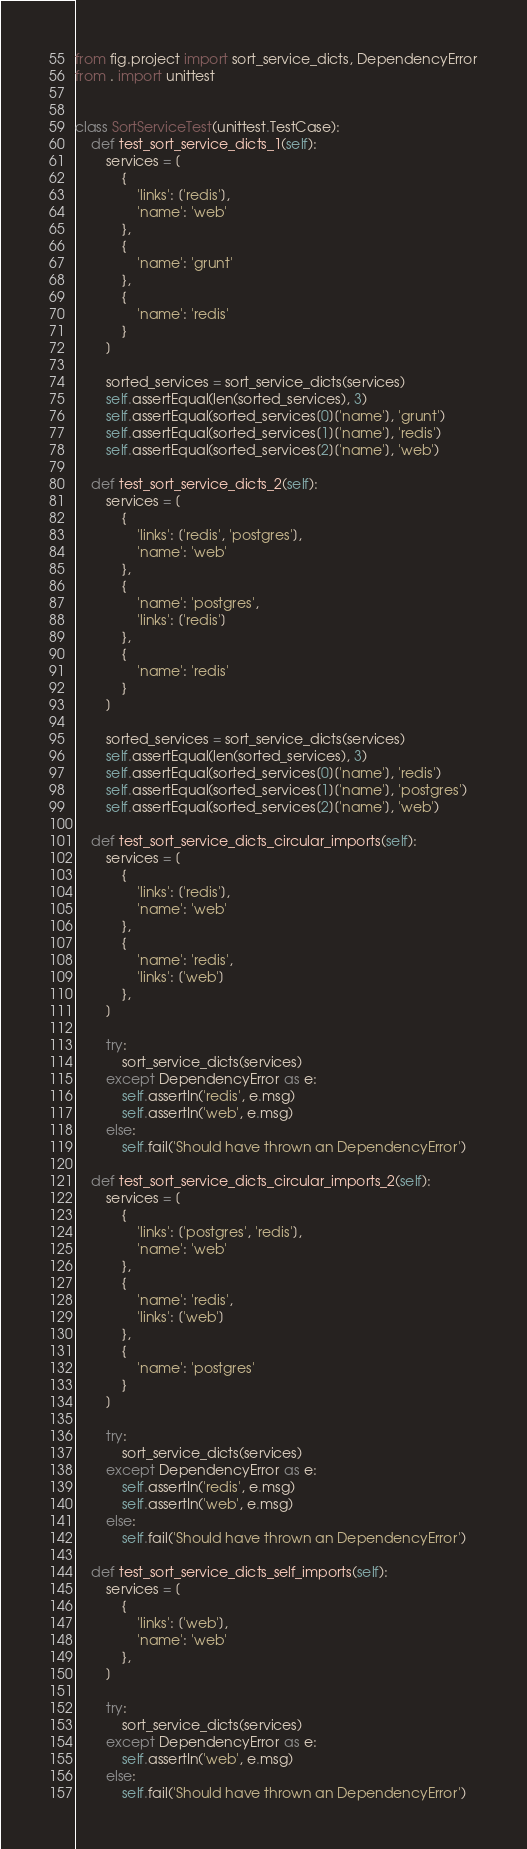<code> <loc_0><loc_0><loc_500><loc_500><_Python_>from fig.project import sort_service_dicts, DependencyError
from . import unittest


class SortServiceTest(unittest.TestCase):
    def test_sort_service_dicts_1(self):
        services = [
            {
                'links': ['redis'],
                'name': 'web'
            },
            {
                'name': 'grunt'
            },
            {
                'name': 'redis'
            }
        ]

        sorted_services = sort_service_dicts(services)
        self.assertEqual(len(sorted_services), 3)
        self.assertEqual(sorted_services[0]['name'], 'grunt')
        self.assertEqual(sorted_services[1]['name'], 'redis')
        self.assertEqual(sorted_services[2]['name'], 'web')

    def test_sort_service_dicts_2(self):
        services = [
            {
                'links': ['redis', 'postgres'],
                'name': 'web'
            },
            {
                'name': 'postgres',
                'links': ['redis']
            },
            {
                'name': 'redis'
            }
        ]

        sorted_services = sort_service_dicts(services)
        self.assertEqual(len(sorted_services), 3)
        self.assertEqual(sorted_services[0]['name'], 'redis')
        self.assertEqual(sorted_services[1]['name'], 'postgres')
        self.assertEqual(sorted_services[2]['name'], 'web')

    def test_sort_service_dicts_circular_imports(self):
        services = [
            {
                'links': ['redis'],
                'name': 'web'
            },
            {
                'name': 'redis',
                'links': ['web']
            },
        ]

        try:
            sort_service_dicts(services)
        except DependencyError as e:
            self.assertIn('redis', e.msg)
            self.assertIn('web', e.msg)
        else:
            self.fail('Should have thrown an DependencyError')

    def test_sort_service_dicts_circular_imports_2(self):
        services = [
            {
                'links': ['postgres', 'redis'],
                'name': 'web'
            },
            {
                'name': 'redis',
                'links': ['web']
            },
            {
                'name': 'postgres'
            }
        ]

        try:
            sort_service_dicts(services)
        except DependencyError as e:
            self.assertIn('redis', e.msg)
            self.assertIn('web', e.msg)
        else:
            self.fail('Should have thrown an DependencyError')

    def test_sort_service_dicts_self_imports(self):
        services = [
            {
                'links': ['web'],
                'name': 'web'
            },
        ]

        try:
            sort_service_dicts(services)
        except DependencyError as e:
            self.assertIn('web', e.msg)
        else:
            self.fail('Should have thrown an DependencyError')
</code> 